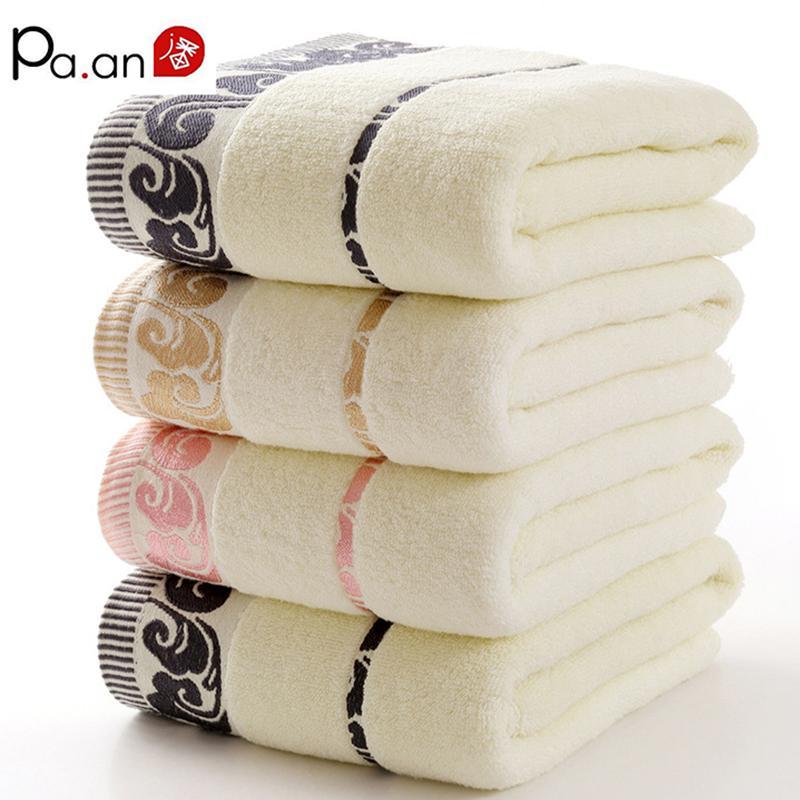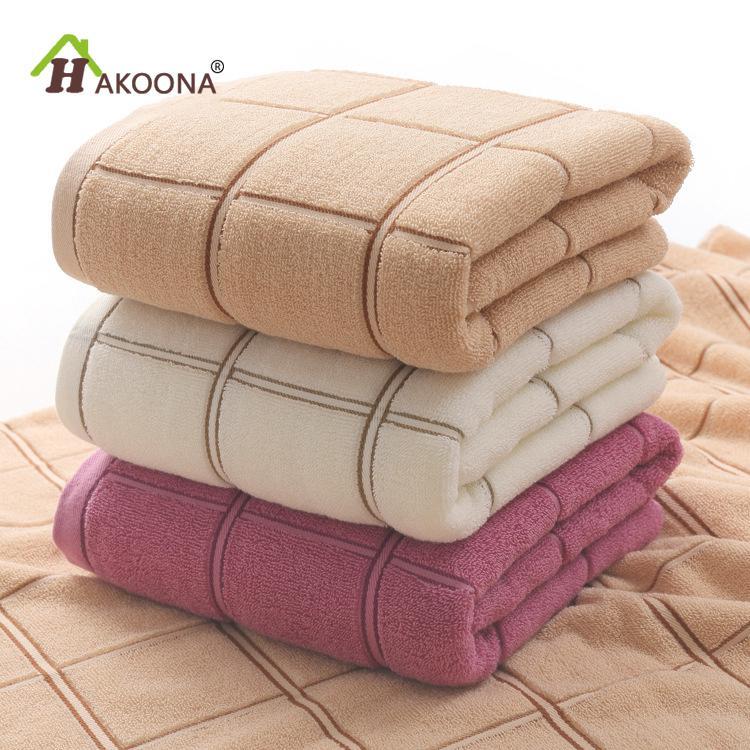The first image is the image on the left, the second image is the image on the right. Examine the images to the left and right. Is the description "There are three folded towels on the right image." accurate? Answer yes or no. Yes. 